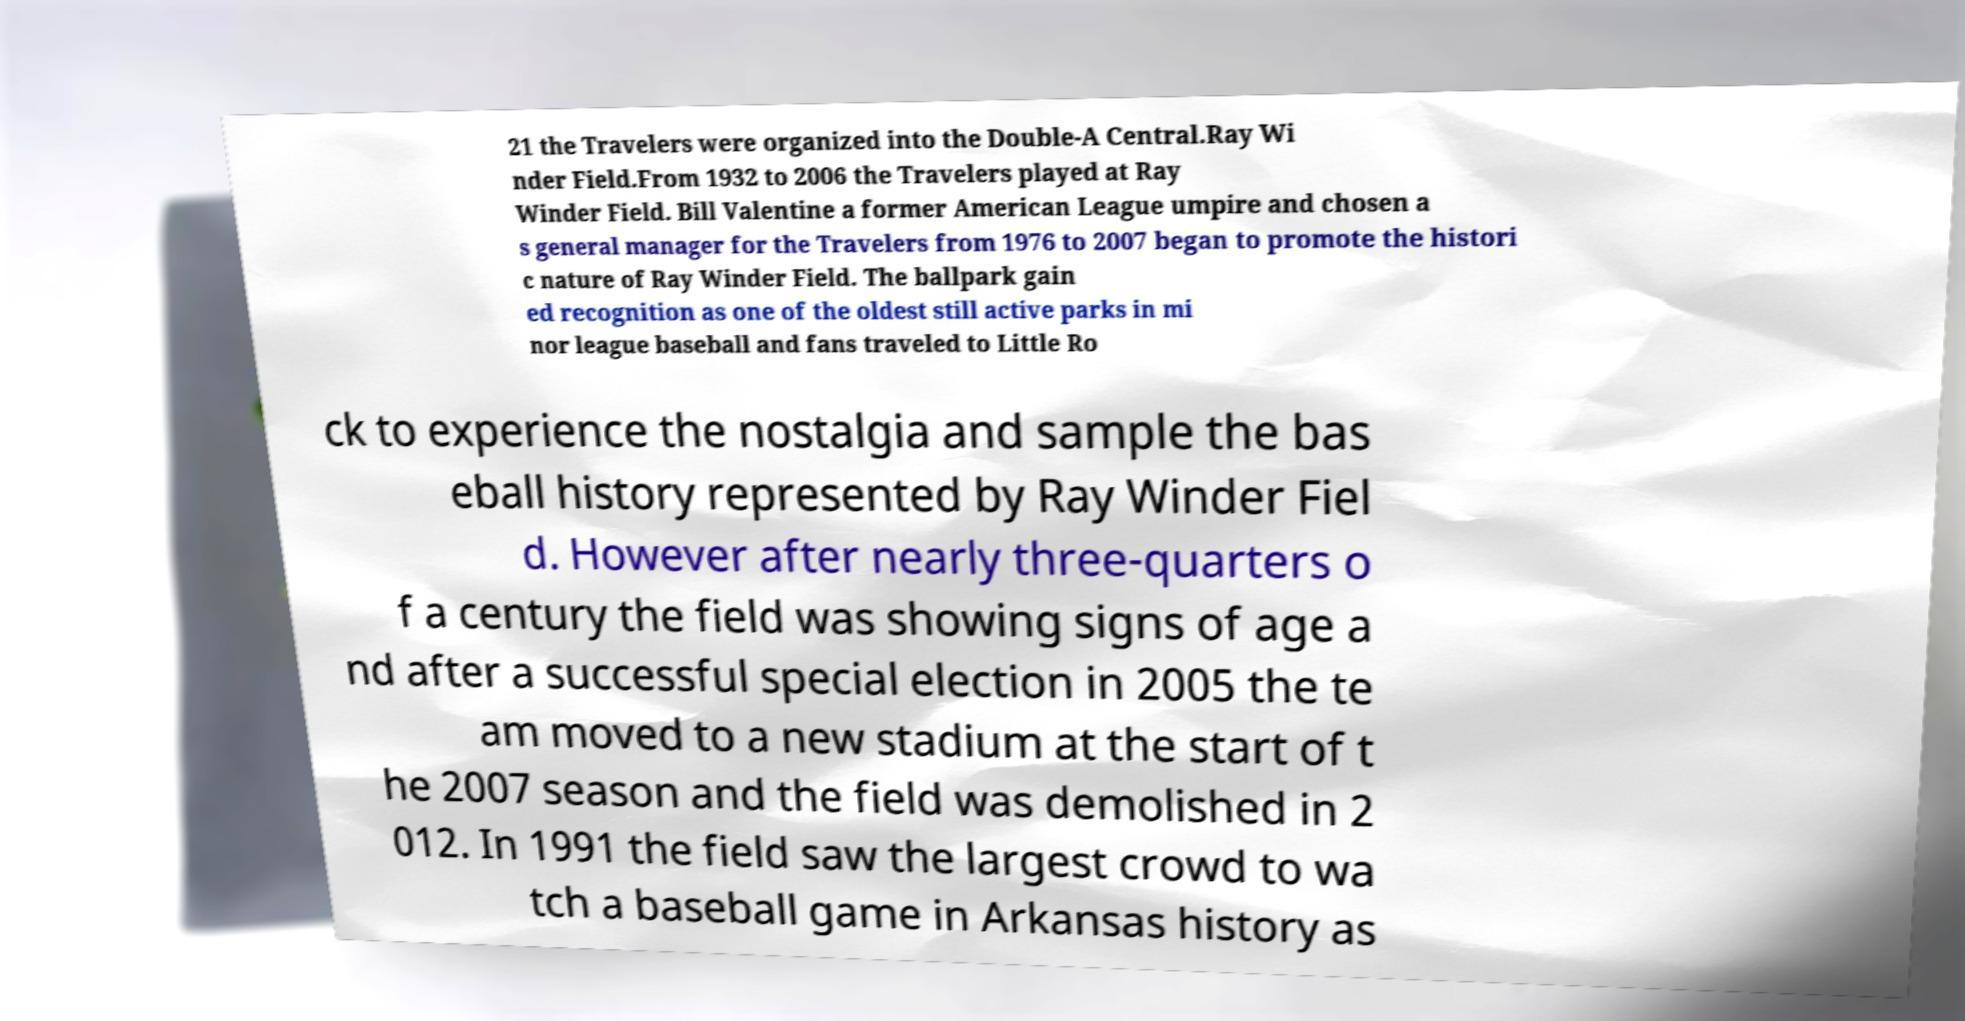Could you extract and type out the text from this image? 21 the Travelers were organized into the Double-A Central.Ray Wi nder Field.From 1932 to 2006 the Travelers played at Ray Winder Field. Bill Valentine a former American League umpire and chosen a s general manager for the Travelers from 1976 to 2007 began to promote the histori c nature of Ray Winder Field. The ballpark gain ed recognition as one of the oldest still active parks in mi nor league baseball and fans traveled to Little Ro ck to experience the nostalgia and sample the bas eball history represented by Ray Winder Fiel d. However after nearly three-quarters o f a century the field was showing signs of age a nd after a successful special election in 2005 the te am moved to a new stadium at the start of t he 2007 season and the field was demolished in 2 012. In 1991 the field saw the largest crowd to wa tch a baseball game in Arkansas history as 